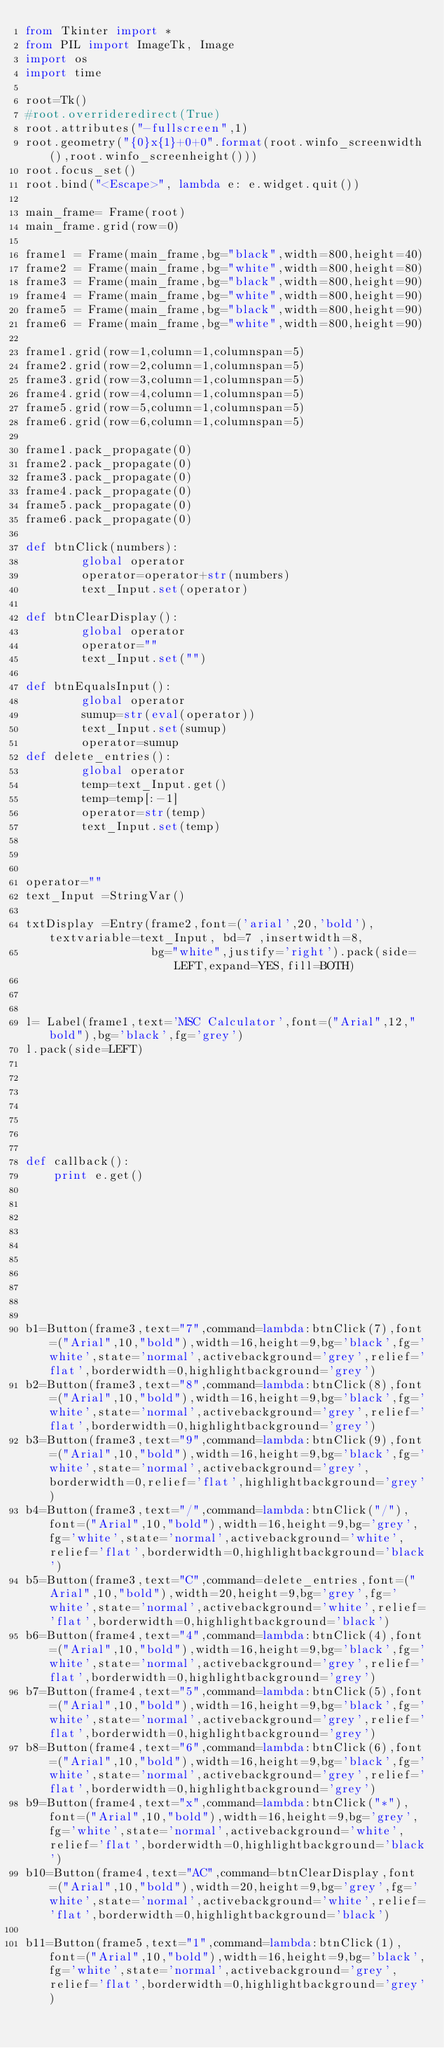<code> <loc_0><loc_0><loc_500><loc_500><_Python_>from Tkinter import *
from PIL import ImageTk, Image
import os
import time

root=Tk()
#root.overrideredirect(True)
root.attributes("-fullscreen",1)
root.geometry("{0}x{1}+0+0".format(root.winfo_screenwidth(),root.winfo_screenheight()))
root.focus_set()
root.bind("<Escape>", lambda e: e.widget.quit())

main_frame= Frame(root)
main_frame.grid(row=0)

frame1 = Frame(main_frame,bg="black",width=800,height=40)
frame2 = Frame(main_frame,bg="white",width=800,height=80)
frame3 = Frame(main_frame,bg="black",width=800,height=90)
frame4 = Frame(main_frame,bg="white",width=800,height=90)
frame5 = Frame(main_frame,bg="black",width=800,height=90)
frame6 = Frame(main_frame,bg="white",width=800,height=90)

frame1.grid(row=1,column=1,columnspan=5)
frame2.grid(row=2,column=1,columnspan=5)
frame3.grid(row=3,column=1,columnspan=5)
frame4.grid(row=4,column=1,columnspan=5)
frame5.grid(row=5,column=1,columnspan=5)
frame6.grid(row=6,column=1,columnspan=5)

frame1.pack_propagate(0)
frame2.pack_propagate(0)
frame3.pack_propagate(0)
frame4.pack_propagate(0)
frame5.pack_propagate(0)
frame6.pack_propagate(0)

def btnClick(numbers):
        global operator
        operator=operator+str(numbers)
        text_Input.set(operator)

def btnClearDisplay():
        global operator
        operator=""
        text_Input.set("")

def btnEqualsInput():
        global operator
        sumup=str(eval(operator))
        text_Input.set(sumup)    
        operator=sumup
def delete_entries():
        global operator
        temp=text_Input.get()
        temp=temp[:-1]
        operator=str(temp)
        text_Input.set(temp)



operator=""
text_Input =StringVar()

txtDisplay =Entry(frame2,font=('arial',20,'bold'),textvariable=text_Input, bd=7 ,insertwidth=8,
                  bg="white",justify='right').pack(side=LEFT,expand=YES,fill=BOTH)



l= Label(frame1,text='MSC Calculator',font=("Arial",12,"bold"),bg='black',fg='grey')
l.pack(side=LEFT)







def callback():
    print e.get()










b1=Button(frame3,text="7",command=lambda:btnClick(7),font=("Arial",10,"bold"),width=16,height=9,bg='black',fg='white',state='normal',activebackground='grey',relief='flat',borderwidth=0,highlightbackground='grey')
b2=Button(frame3,text="8",command=lambda:btnClick(8),font=("Arial",10,"bold"),width=16,height=9,bg='black',fg='white',state='normal',activebackground='grey',relief='flat',borderwidth=0,highlightbackground='grey')
b3=Button(frame3,text="9",command=lambda:btnClick(9),font=("Arial",10,"bold"),width=16,height=9,bg='black',fg='white',state='normal',activebackground='grey',borderwidth=0,relief='flat',highlightbackground='grey')
b4=Button(frame3,text="/",command=lambda:btnClick("/"),font=("Arial",10,"bold"),width=16,height=9,bg='grey',fg='white',state='normal',activebackground='white',relief='flat',borderwidth=0,highlightbackground='black')
b5=Button(frame3,text="C",command=delete_entries,font=("Arial",10,"bold"),width=20,height=9,bg='grey',fg='white',state='normal',activebackground='white',relief='flat',borderwidth=0,highlightbackground='black')
b6=Button(frame4,text="4",command=lambda:btnClick(4),font=("Arial",10,"bold"),width=16,height=9,bg='black',fg='white',state='normal',activebackground='grey',relief='flat',borderwidth=0,highlightbackground='grey')
b7=Button(frame4,text="5",command=lambda:btnClick(5),font=("Arial",10,"bold"),width=16,height=9,bg='black',fg='white',state='normal',activebackground='grey',relief='flat',borderwidth=0,highlightbackground='grey')
b8=Button(frame4,text="6",command=lambda:btnClick(6),font=("Arial",10,"bold"),width=16,height=9,bg='black',fg='white',state='normal',activebackground='grey',relief='flat',borderwidth=0,highlightbackground='grey')
b9=Button(frame4,text="x",command=lambda:btnClick("*"),font=("Arial",10,"bold"),width=16,height=9,bg='grey',fg='white',state='normal',activebackground='white',relief='flat',borderwidth=0,highlightbackground='black')
b10=Button(frame4,text="AC",command=btnClearDisplay,font=("Arial",10,"bold"),width=20,height=9,bg='grey',fg='white',state='normal',activebackground='white',relief='flat',borderwidth=0,highlightbackground='black')

b11=Button(frame5,text="1",command=lambda:btnClick(1),font=("Arial",10,"bold"),width=16,height=9,bg='black',fg='white',state='normal',activebackground='grey',relief='flat',borderwidth=0,highlightbackground='grey')</code> 